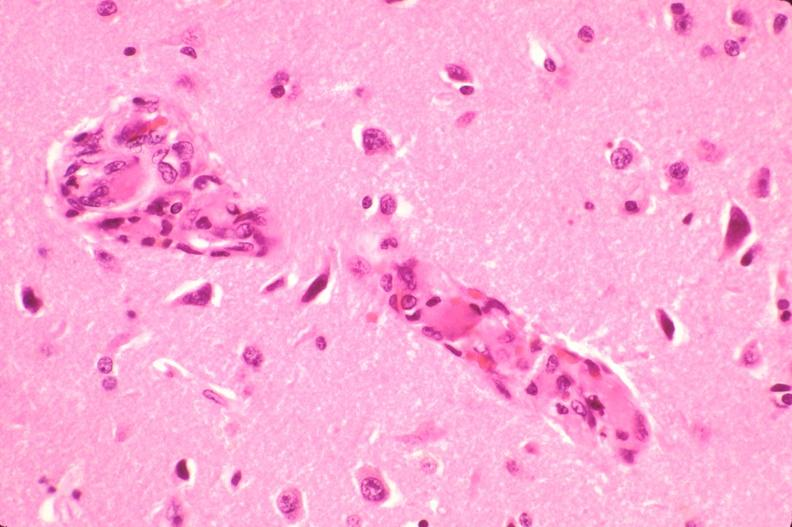s nervous present?
Answer the question using a single word or phrase. Yes 